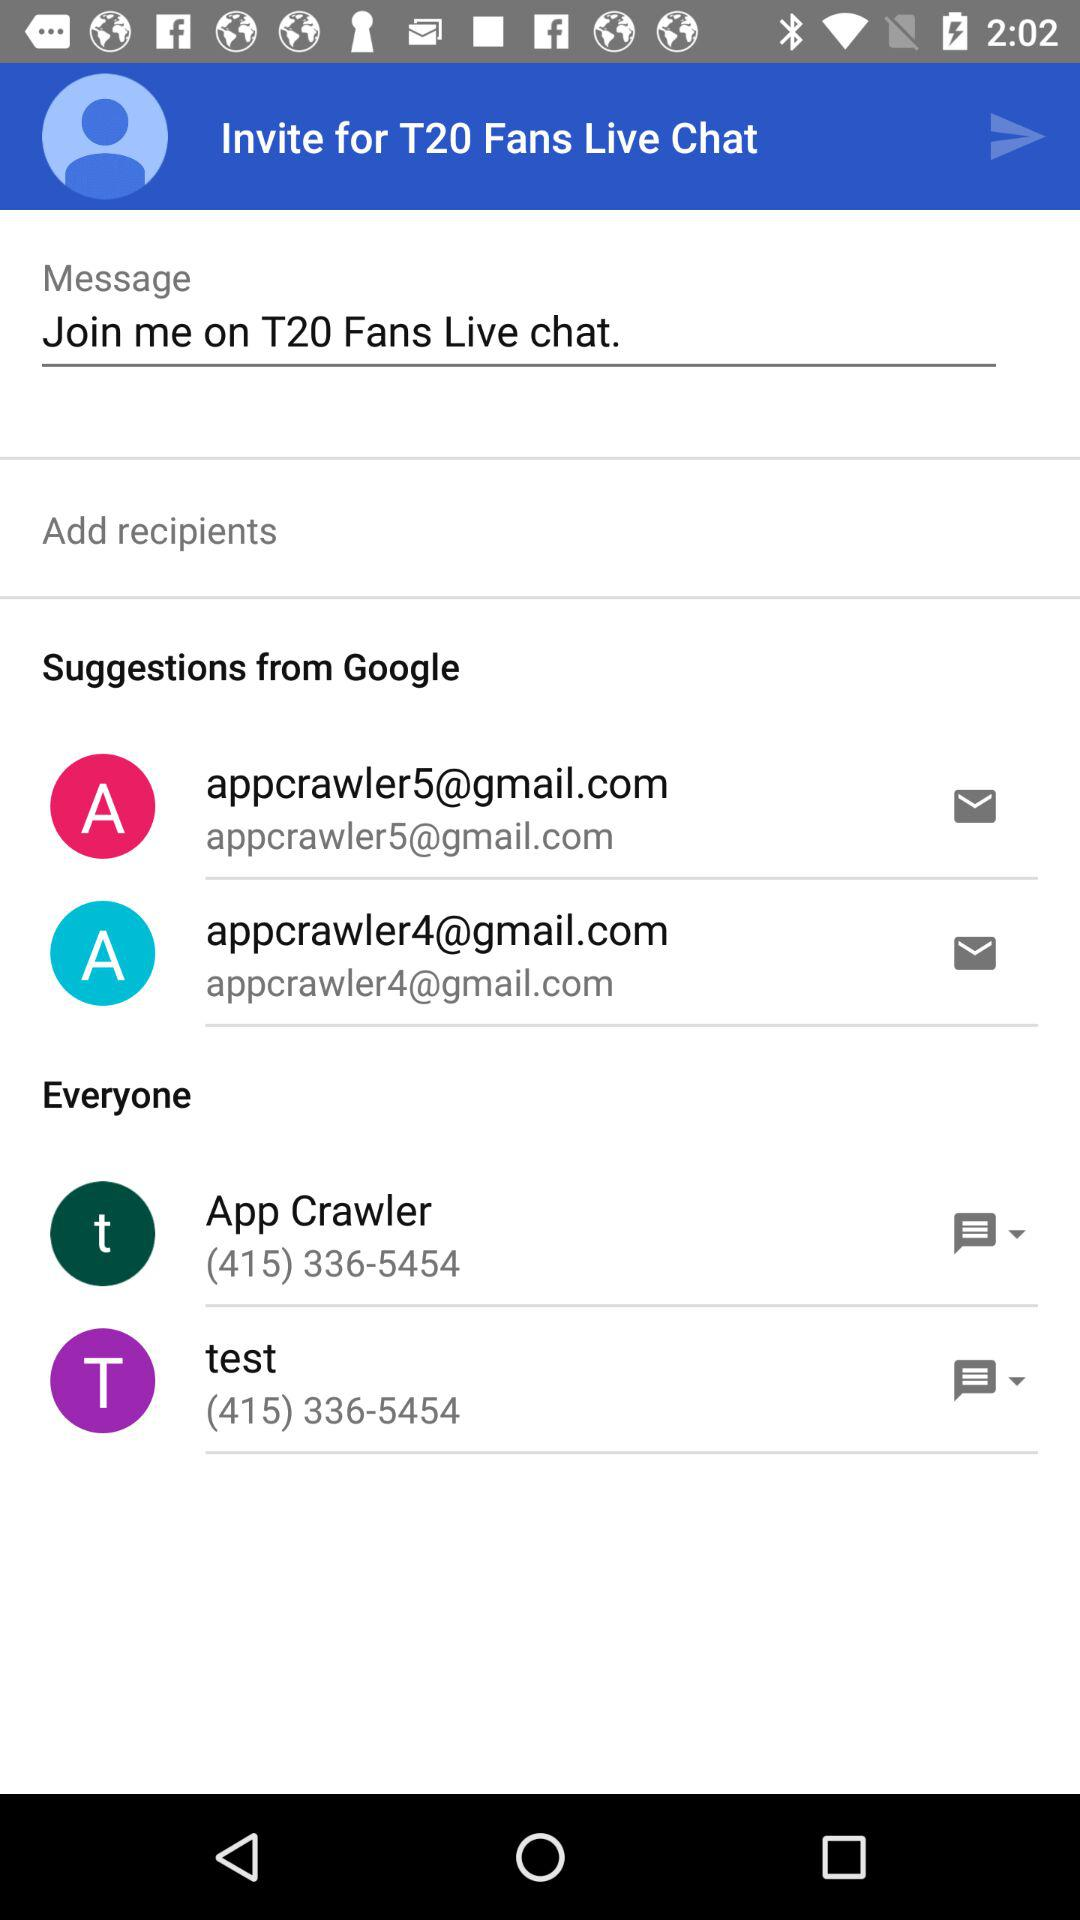What is the message written? The message written is "Join me on T20 Fans Live chat.". 